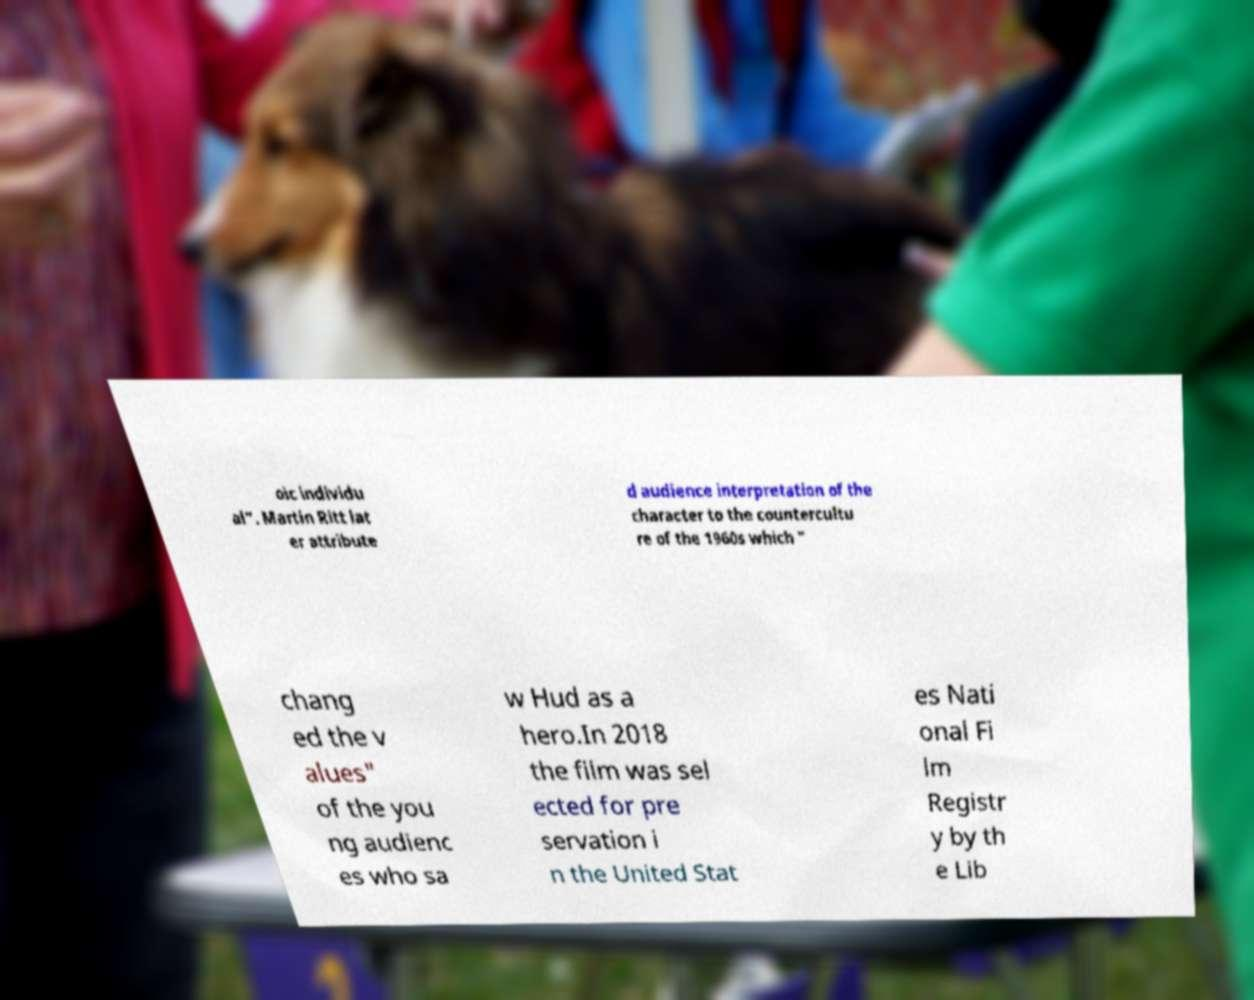Could you extract and type out the text from this image? oic individu al". Martin Ritt lat er attribute d audience interpretation of the character to the countercultu re of the 1960s which " chang ed the v alues" of the you ng audienc es who sa w Hud as a hero.In 2018 the film was sel ected for pre servation i n the United Stat es Nati onal Fi lm Registr y by th e Lib 